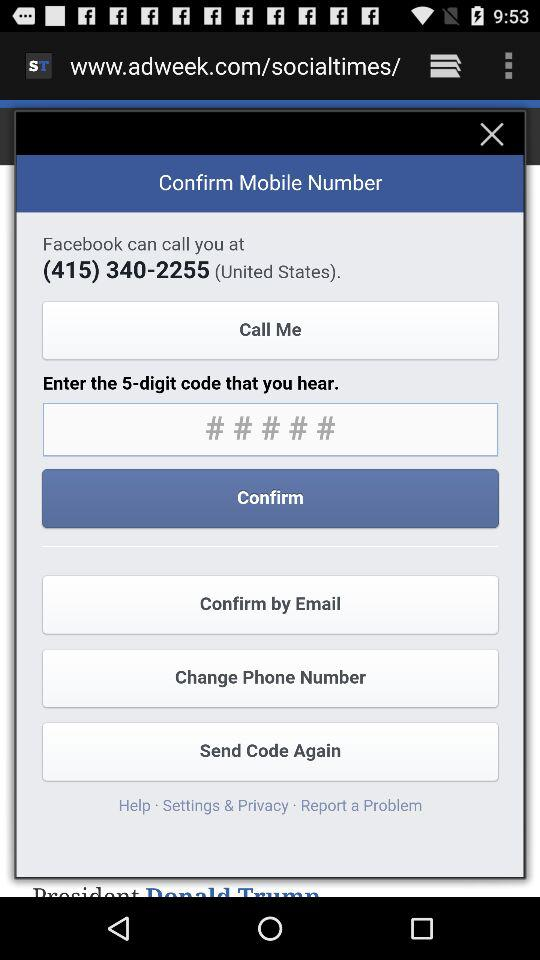What country is mentioned? The mentioned country is the United States. 